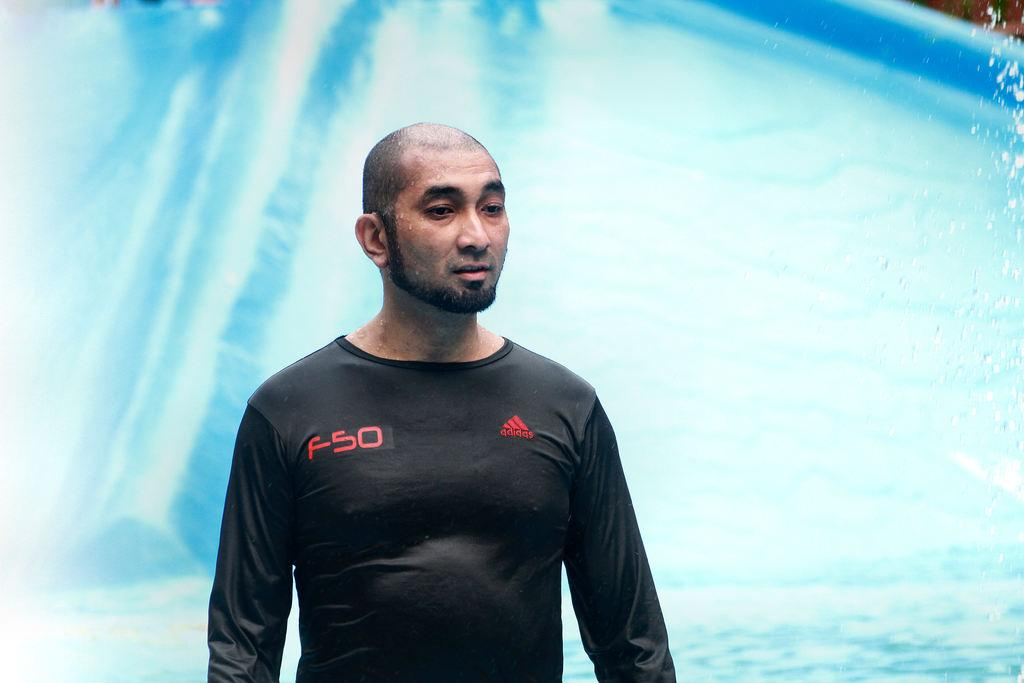Who or what is present in the image? There is a person in the image. What is the person wearing? The person is wearing a black t-shirt. What can be seen in the background of the image? There is a slope and water visible in the background of the image. What type of drug is the person holding in the image? There is no drug present in the image; the person is wearing a black t-shirt and there is a slope and water visible in the background. 